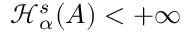<formula> <loc_0><loc_0><loc_500><loc_500>\mathcal { H } _ { \alpha } ^ { s } ( A ) < + \infty</formula> 